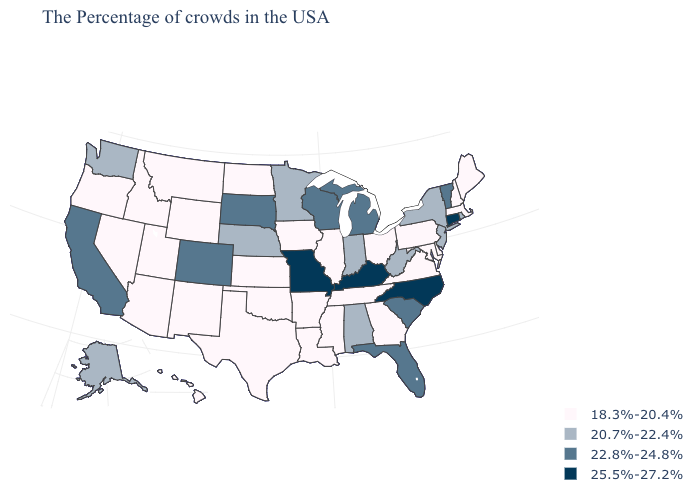Name the states that have a value in the range 20.7%-22.4%?
Give a very brief answer. Rhode Island, New York, New Jersey, West Virginia, Indiana, Alabama, Minnesota, Nebraska, Washington, Alaska. Does the map have missing data?
Write a very short answer. No. Does Missouri have the lowest value in the MidWest?
Answer briefly. No. Does Vermont have the same value as Alabama?
Concise answer only. No. Name the states that have a value in the range 18.3%-20.4%?
Be succinct. Maine, Massachusetts, New Hampshire, Delaware, Maryland, Pennsylvania, Virginia, Ohio, Georgia, Tennessee, Illinois, Mississippi, Louisiana, Arkansas, Iowa, Kansas, Oklahoma, Texas, North Dakota, Wyoming, New Mexico, Utah, Montana, Arizona, Idaho, Nevada, Oregon, Hawaii. What is the highest value in states that border Iowa?
Answer briefly. 25.5%-27.2%. What is the value of North Dakota?
Write a very short answer. 18.3%-20.4%. Which states have the lowest value in the MidWest?
Give a very brief answer. Ohio, Illinois, Iowa, Kansas, North Dakota. Name the states that have a value in the range 20.7%-22.4%?
Answer briefly. Rhode Island, New York, New Jersey, West Virginia, Indiana, Alabama, Minnesota, Nebraska, Washington, Alaska. What is the lowest value in states that border Montana?
Give a very brief answer. 18.3%-20.4%. What is the value of Michigan?
Short answer required. 22.8%-24.8%. Name the states that have a value in the range 20.7%-22.4%?
Short answer required. Rhode Island, New York, New Jersey, West Virginia, Indiana, Alabama, Minnesota, Nebraska, Washington, Alaska. Does the map have missing data?
Be succinct. No. Among the states that border Michigan , which have the highest value?
Be succinct. Wisconsin. Does Arizona have the same value as Florida?
Short answer required. No. 